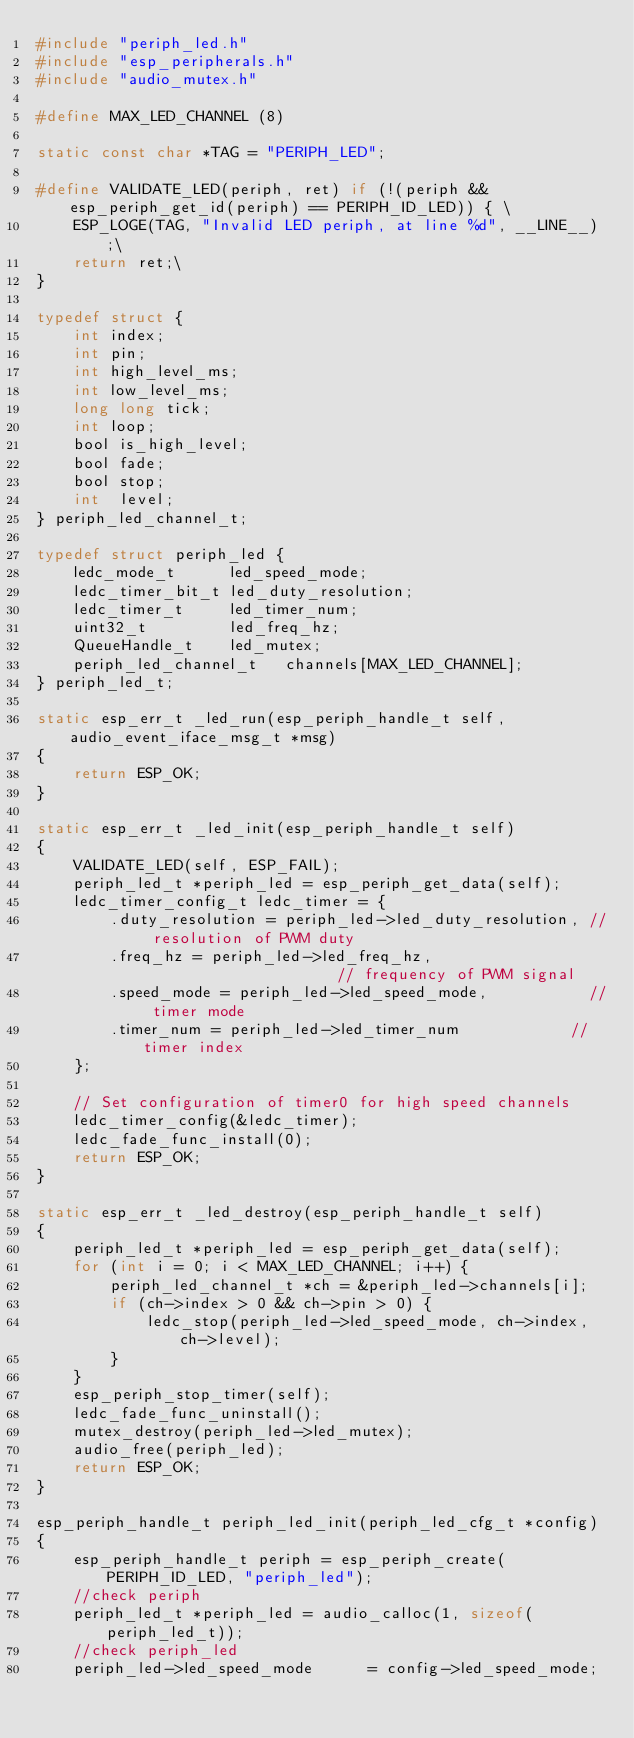Convert code to text. <code><loc_0><loc_0><loc_500><loc_500><_C_>#include "periph_led.h"
#include "esp_peripherals.h"
#include "audio_mutex.h"

#define MAX_LED_CHANNEL (8)

static const char *TAG = "PERIPH_LED";

#define VALIDATE_LED(periph, ret) if (!(periph && esp_periph_get_id(periph) == PERIPH_ID_LED)) { \
    ESP_LOGE(TAG, "Invalid LED periph, at line %d", __LINE__);\
    return ret;\
}

typedef struct {
    int index;
    int pin;
    int high_level_ms;
    int low_level_ms;
    long long tick;
    int loop;
    bool is_high_level;
    bool fade;
    bool stop;
    int  level;
} periph_led_channel_t;

typedef struct periph_led {
    ledc_mode_t      led_speed_mode;
    ledc_timer_bit_t led_duty_resolution;
    ledc_timer_t     led_timer_num;
    uint32_t         led_freq_hz;
    QueueHandle_t    led_mutex;
    periph_led_channel_t   channels[MAX_LED_CHANNEL];
} periph_led_t;

static esp_err_t _led_run(esp_periph_handle_t self, audio_event_iface_msg_t *msg)
{
    return ESP_OK;
}

static esp_err_t _led_init(esp_periph_handle_t self)
{
    VALIDATE_LED(self, ESP_FAIL);
    periph_led_t *periph_led = esp_periph_get_data(self);
    ledc_timer_config_t ledc_timer = {
        .duty_resolution = periph_led->led_duty_resolution, // resolution of PWM duty
        .freq_hz = periph_led->led_freq_hz,                      // frequency of PWM signal
        .speed_mode = periph_led->led_speed_mode,           // timer mode
        .timer_num = periph_led->led_timer_num            // timer index
    };

    // Set configuration of timer0 for high speed channels
    ledc_timer_config(&ledc_timer);
    ledc_fade_func_install(0);
    return ESP_OK;
}

static esp_err_t _led_destroy(esp_periph_handle_t self)
{
    periph_led_t *periph_led = esp_periph_get_data(self);
    for (int i = 0; i < MAX_LED_CHANNEL; i++) {
        periph_led_channel_t *ch = &periph_led->channels[i];
        if (ch->index > 0 && ch->pin > 0) {
            ledc_stop(periph_led->led_speed_mode, ch->index, ch->level);
        }
    }
    esp_periph_stop_timer(self);
    ledc_fade_func_uninstall();
    mutex_destroy(periph_led->led_mutex);
    audio_free(periph_led);
    return ESP_OK;
}

esp_periph_handle_t periph_led_init(periph_led_cfg_t *config)
{
    esp_periph_handle_t periph = esp_periph_create(PERIPH_ID_LED, "periph_led");
    //check periph
    periph_led_t *periph_led = audio_calloc(1, sizeof(periph_led_t));
    //check periph_led
    periph_led->led_speed_mode      = config->led_speed_mode;</code> 